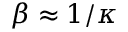Convert formula to latex. <formula><loc_0><loc_0><loc_500><loc_500>\beta \approx 1 / \kappa</formula> 